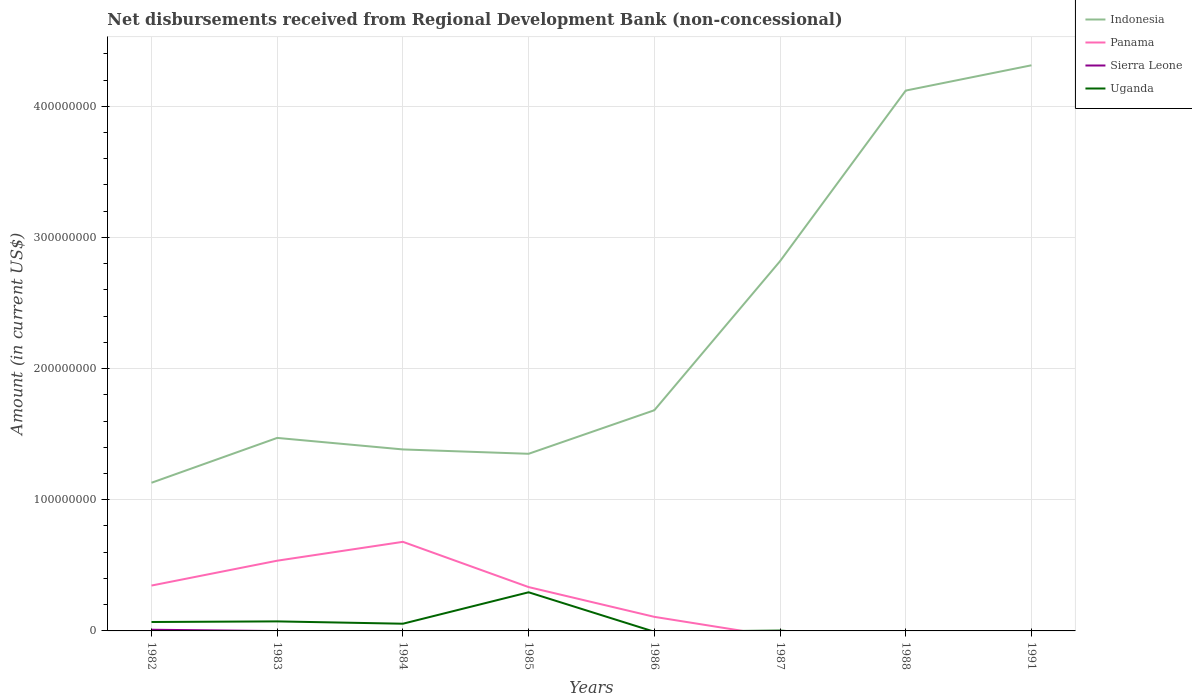How many different coloured lines are there?
Ensure brevity in your answer.  4. Does the line corresponding to Panama intersect with the line corresponding to Sierra Leone?
Provide a short and direct response. Yes. Is the number of lines equal to the number of legend labels?
Your answer should be compact. No. Across all years, what is the maximum amount of disbursements received from Regional Development Bank in Indonesia?
Provide a short and direct response. 1.13e+08. What is the total amount of disbursements received from Regional Development Bank in Indonesia in the graph?
Make the answer very short. -2.96e+08. What is the difference between the highest and the second highest amount of disbursements received from Regional Development Bank in Panama?
Provide a succinct answer. 6.79e+07. What is the difference between the highest and the lowest amount of disbursements received from Regional Development Bank in Uganda?
Ensure brevity in your answer.  3. Is the amount of disbursements received from Regional Development Bank in Uganda strictly greater than the amount of disbursements received from Regional Development Bank in Panama over the years?
Provide a short and direct response. No. How many lines are there?
Give a very brief answer. 4. What is the difference between two consecutive major ticks on the Y-axis?
Provide a succinct answer. 1.00e+08. Are the values on the major ticks of Y-axis written in scientific E-notation?
Provide a short and direct response. No. Does the graph contain any zero values?
Your answer should be compact. Yes. Does the graph contain grids?
Make the answer very short. Yes. How many legend labels are there?
Offer a very short reply. 4. What is the title of the graph?
Offer a terse response. Net disbursements received from Regional Development Bank (non-concessional). What is the Amount (in current US$) in Indonesia in 1982?
Provide a succinct answer. 1.13e+08. What is the Amount (in current US$) in Panama in 1982?
Offer a terse response. 3.46e+07. What is the Amount (in current US$) of Sierra Leone in 1982?
Keep it short and to the point. 9.06e+05. What is the Amount (in current US$) in Uganda in 1982?
Your response must be concise. 6.80e+06. What is the Amount (in current US$) in Indonesia in 1983?
Provide a succinct answer. 1.47e+08. What is the Amount (in current US$) of Panama in 1983?
Your answer should be compact. 5.35e+07. What is the Amount (in current US$) of Uganda in 1983?
Make the answer very short. 7.27e+06. What is the Amount (in current US$) in Indonesia in 1984?
Keep it short and to the point. 1.38e+08. What is the Amount (in current US$) of Panama in 1984?
Ensure brevity in your answer.  6.79e+07. What is the Amount (in current US$) of Uganda in 1984?
Keep it short and to the point. 5.49e+06. What is the Amount (in current US$) of Indonesia in 1985?
Provide a succinct answer. 1.35e+08. What is the Amount (in current US$) in Panama in 1985?
Your answer should be very brief. 3.34e+07. What is the Amount (in current US$) of Uganda in 1985?
Your answer should be very brief. 2.95e+07. What is the Amount (in current US$) in Indonesia in 1986?
Your answer should be compact. 1.68e+08. What is the Amount (in current US$) of Panama in 1986?
Your answer should be compact. 1.07e+07. What is the Amount (in current US$) of Sierra Leone in 1986?
Offer a very short reply. 0. What is the Amount (in current US$) of Indonesia in 1987?
Your response must be concise. 2.82e+08. What is the Amount (in current US$) in Sierra Leone in 1987?
Ensure brevity in your answer.  0. What is the Amount (in current US$) in Uganda in 1987?
Offer a terse response. 2.63e+05. What is the Amount (in current US$) of Indonesia in 1988?
Offer a terse response. 4.12e+08. What is the Amount (in current US$) of Panama in 1988?
Keep it short and to the point. 0. What is the Amount (in current US$) in Sierra Leone in 1988?
Your response must be concise. 0. What is the Amount (in current US$) of Uganda in 1988?
Keep it short and to the point. 0. What is the Amount (in current US$) of Indonesia in 1991?
Provide a short and direct response. 4.31e+08. What is the Amount (in current US$) of Panama in 1991?
Offer a very short reply. 0. Across all years, what is the maximum Amount (in current US$) of Indonesia?
Make the answer very short. 4.31e+08. Across all years, what is the maximum Amount (in current US$) of Panama?
Keep it short and to the point. 6.79e+07. Across all years, what is the maximum Amount (in current US$) of Sierra Leone?
Give a very brief answer. 9.06e+05. Across all years, what is the maximum Amount (in current US$) of Uganda?
Provide a short and direct response. 2.95e+07. Across all years, what is the minimum Amount (in current US$) in Indonesia?
Provide a short and direct response. 1.13e+08. Across all years, what is the minimum Amount (in current US$) in Uganda?
Offer a very short reply. 0. What is the total Amount (in current US$) of Indonesia in the graph?
Your answer should be very brief. 1.83e+09. What is the total Amount (in current US$) in Panama in the graph?
Ensure brevity in your answer.  2.00e+08. What is the total Amount (in current US$) in Sierra Leone in the graph?
Ensure brevity in your answer.  9.06e+05. What is the total Amount (in current US$) of Uganda in the graph?
Offer a very short reply. 4.93e+07. What is the difference between the Amount (in current US$) of Indonesia in 1982 and that in 1983?
Offer a very short reply. -3.42e+07. What is the difference between the Amount (in current US$) in Panama in 1982 and that in 1983?
Your answer should be compact. -1.90e+07. What is the difference between the Amount (in current US$) of Uganda in 1982 and that in 1983?
Make the answer very short. -4.67e+05. What is the difference between the Amount (in current US$) of Indonesia in 1982 and that in 1984?
Your answer should be very brief. -2.54e+07. What is the difference between the Amount (in current US$) of Panama in 1982 and that in 1984?
Provide a succinct answer. -3.33e+07. What is the difference between the Amount (in current US$) of Uganda in 1982 and that in 1984?
Offer a terse response. 1.31e+06. What is the difference between the Amount (in current US$) in Indonesia in 1982 and that in 1985?
Your answer should be compact. -2.21e+07. What is the difference between the Amount (in current US$) of Panama in 1982 and that in 1985?
Your answer should be very brief. 1.17e+06. What is the difference between the Amount (in current US$) in Uganda in 1982 and that in 1985?
Give a very brief answer. -2.27e+07. What is the difference between the Amount (in current US$) of Indonesia in 1982 and that in 1986?
Offer a very short reply. -5.53e+07. What is the difference between the Amount (in current US$) of Panama in 1982 and that in 1986?
Offer a very short reply. 2.39e+07. What is the difference between the Amount (in current US$) in Indonesia in 1982 and that in 1987?
Offer a very short reply. -1.69e+08. What is the difference between the Amount (in current US$) in Uganda in 1982 and that in 1987?
Offer a terse response. 6.54e+06. What is the difference between the Amount (in current US$) in Indonesia in 1982 and that in 1988?
Ensure brevity in your answer.  -2.99e+08. What is the difference between the Amount (in current US$) in Indonesia in 1982 and that in 1991?
Your answer should be compact. -3.18e+08. What is the difference between the Amount (in current US$) in Indonesia in 1983 and that in 1984?
Your answer should be compact. 8.79e+06. What is the difference between the Amount (in current US$) of Panama in 1983 and that in 1984?
Your response must be concise. -1.44e+07. What is the difference between the Amount (in current US$) in Uganda in 1983 and that in 1984?
Your response must be concise. 1.78e+06. What is the difference between the Amount (in current US$) in Indonesia in 1983 and that in 1985?
Your response must be concise. 1.21e+07. What is the difference between the Amount (in current US$) of Panama in 1983 and that in 1985?
Offer a terse response. 2.01e+07. What is the difference between the Amount (in current US$) of Uganda in 1983 and that in 1985?
Ensure brevity in your answer.  -2.22e+07. What is the difference between the Amount (in current US$) in Indonesia in 1983 and that in 1986?
Make the answer very short. -2.11e+07. What is the difference between the Amount (in current US$) of Panama in 1983 and that in 1986?
Your response must be concise. 4.28e+07. What is the difference between the Amount (in current US$) in Indonesia in 1983 and that in 1987?
Give a very brief answer. -1.35e+08. What is the difference between the Amount (in current US$) of Uganda in 1983 and that in 1987?
Your response must be concise. 7.01e+06. What is the difference between the Amount (in current US$) of Indonesia in 1983 and that in 1988?
Ensure brevity in your answer.  -2.65e+08. What is the difference between the Amount (in current US$) of Indonesia in 1983 and that in 1991?
Ensure brevity in your answer.  -2.84e+08. What is the difference between the Amount (in current US$) of Indonesia in 1984 and that in 1985?
Your answer should be compact. 3.32e+06. What is the difference between the Amount (in current US$) of Panama in 1984 and that in 1985?
Your response must be concise. 3.45e+07. What is the difference between the Amount (in current US$) of Uganda in 1984 and that in 1985?
Your response must be concise. -2.40e+07. What is the difference between the Amount (in current US$) of Indonesia in 1984 and that in 1986?
Give a very brief answer. -2.99e+07. What is the difference between the Amount (in current US$) of Panama in 1984 and that in 1986?
Ensure brevity in your answer.  5.72e+07. What is the difference between the Amount (in current US$) in Indonesia in 1984 and that in 1987?
Make the answer very short. -1.44e+08. What is the difference between the Amount (in current US$) in Uganda in 1984 and that in 1987?
Give a very brief answer. 5.23e+06. What is the difference between the Amount (in current US$) in Indonesia in 1984 and that in 1988?
Make the answer very short. -2.74e+08. What is the difference between the Amount (in current US$) in Indonesia in 1984 and that in 1991?
Ensure brevity in your answer.  -2.93e+08. What is the difference between the Amount (in current US$) in Indonesia in 1985 and that in 1986?
Offer a very short reply. -3.32e+07. What is the difference between the Amount (in current US$) of Panama in 1985 and that in 1986?
Offer a terse response. 2.27e+07. What is the difference between the Amount (in current US$) of Indonesia in 1985 and that in 1987?
Your answer should be compact. -1.47e+08. What is the difference between the Amount (in current US$) of Uganda in 1985 and that in 1987?
Give a very brief answer. 2.92e+07. What is the difference between the Amount (in current US$) in Indonesia in 1985 and that in 1988?
Your answer should be very brief. -2.77e+08. What is the difference between the Amount (in current US$) in Indonesia in 1985 and that in 1991?
Give a very brief answer. -2.96e+08. What is the difference between the Amount (in current US$) in Indonesia in 1986 and that in 1987?
Provide a short and direct response. -1.14e+08. What is the difference between the Amount (in current US$) of Indonesia in 1986 and that in 1988?
Make the answer very short. -2.44e+08. What is the difference between the Amount (in current US$) in Indonesia in 1986 and that in 1991?
Keep it short and to the point. -2.63e+08. What is the difference between the Amount (in current US$) of Indonesia in 1987 and that in 1988?
Offer a very short reply. -1.30e+08. What is the difference between the Amount (in current US$) in Indonesia in 1987 and that in 1991?
Your answer should be compact. -1.49e+08. What is the difference between the Amount (in current US$) in Indonesia in 1988 and that in 1991?
Provide a succinct answer. -1.93e+07. What is the difference between the Amount (in current US$) in Indonesia in 1982 and the Amount (in current US$) in Panama in 1983?
Provide a short and direct response. 5.94e+07. What is the difference between the Amount (in current US$) in Indonesia in 1982 and the Amount (in current US$) in Uganda in 1983?
Your response must be concise. 1.06e+08. What is the difference between the Amount (in current US$) of Panama in 1982 and the Amount (in current US$) of Uganda in 1983?
Provide a succinct answer. 2.73e+07. What is the difference between the Amount (in current US$) of Sierra Leone in 1982 and the Amount (in current US$) of Uganda in 1983?
Provide a short and direct response. -6.36e+06. What is the difference between the Amount (in current US$) of Indonesia in 1982 and the Amount (in current US$) of Panama in 1984?
Your answer should be very brief. 4.50e+07. What is the difference between the Amount (in current US$) of Indonesia in 1982 and the Amount (in current US$) of Uganda in 1984?
Make the answer very short. 1.07e+08. What is the difference between the Amount (in current US$) in Panama in 1982 and the Amount (in current US$) in Uganda in 1984?
Provide a short and direct response. 2.91e+07. What is the difference between the Amount (in current US$) in Sierra Leone in 1982 and the Amount (in current US$) in Uganda in 1984?
Keep it short and to the point. -4.58e+06. What is the difference between the Amount (in current US$) of Indonesia in 1982 and the Amount (in current US$) of Panama in 1985?
Your response must be concise. 7.95e+07. What is the difference between the Amount (in current US$) in Indonesia in 1982 and the Amount (in current US$) in Uganda in 1985?
Offer a terse response. 8.35e+07. What is the difference between the Amount (in current US$) of Panama in 1982 and the Amount (in current US$) of Uganda in 1985?
Offer a very short reply. 5.12e+06. What is the difference between the Amount (in current US$) in Sierra Leone in 1982 and the Amount (in current US$) in Uganda in 1985?
Keep it short and to the point. -2.86e+07. What is the difference between the Amount (in current US$) in Indonesia in 1982 and the Amount (in current US$) in Panama in 1986?
Offer a very short reply. 1.02e+08. What is the difference between the Amount (in current US$) of Indonesia in 1982 and the Amount (in current US$) of Uganda in 1987?
Give a very brief answer. 1.13e+08. What is the difference between the Amount (in current US$) of Panama in 1982 and the Amount (in current US$) of Uganda in 1987?
Offer a very short reply. 3.43e+07. What is the difference between the Amount (in current US$) in Sierra Leone in 1982 and the Amount (in current US$) in Uganda in 1987?
Your answer should be compact. 6.43e+05. What is the difference between the Amount (in current US$) of Indonesia in 1983 and the Amount (in current US$) of Panama in 1984?
Keep it short and to the point. 7.92e+07. What is the difference between the Amount (in current US$) of Indonesia in 1983 and the Amount (in current US$) of Uganda in 1984?
Give a very brief answer. 1.42e+08. What is the difference between the Amount (in current US$) of Panama in 1983 and the Amount (in current US$) of Uganda in 1984?
Provide a short and direct response. 4.80e+07. What is the difference between the Amount (in current US$) in Indonesia in 1983 and the Amount (in current US$) in Panama in 1985?
Ensure brevity in your answer.  1.14e+08. What is the difference between the Amount (in current US$) in Indonesia in 1983 and the Amount (in current US$) in Uganda in 1985?
Keep it short and to the point. 1.18e+08. What is the difference between the Amount (in current US$) in Panama in 1983 and the Amount (in current US$) in Uganda in 1985?
Give a very brief answer. 2.41e+07. What is the difference between the Amount (in current US$) of Indonesia in 1983 and the Amount (in current US$) of Panama in 1986?
Offer a terse response. 1.36e+08. What is the difference between the Amount (in current US$) of Indonesia in 1983 and the Amount (in current US$) of Uganda in 1987?
Your response must be concise. 1.47e+08. What is the difference between the Amount (in current US$) of Panama in 1983 and the Amount (in current US$) of Uganda in 1987?
Your answer should be very brief. 5.33e+07. What is the difference between the Amount (in current US$) of Indonesia in 1984 and the Amount (in current US$) of Panama in 1985?
Provide a succinct answer. 1.05e+08. What is the difference between the Amount (in current US$) of Indonesia in 1984 and the Amount (in current US$) of Uganda in 1985?
Provide a succinct answer. 1.09e+08. What is the difference between the Amount (in current US$) of Panama in 1984 and the Amount (in current US$) of Uganda in 1985?
Provide a succinct answer. 3.85e+07. What is the difference between the Amount (in current US$) in Indonesia in 1984 and the Amount (in current US$) in Panama in 1986?
Your response must be concise. 1.28e+08. What is the difference between the Amount (in current US$) in Indonesia in 1984 and the Amount (in current US$) in Uganda in 1987?
Provide a short and direct response. 1.38e+08. What is the difference between the Amount (in current US$) in Panama in 1984 and the Amount (in current US$) in Uganda in 1987?
Your answer should be compact. 6.77e+07. What is the difference between the Amount (in current US$) in Indonesia in 1985 and the Amount (in current US$) in Panama in 1986?
Provide a succinct answer. 1.24e+08. What is the difference between the Amount (in current US$) in Indonesia in 1985 and the Amount (in current US$) in Uganda in 1987?
Keep it short and to the point. 1.35e+08. What is the difference between the Amount (in current US$) of Panama in 1985 and the Amount (in current US$) of Uganda in 1987?
Provide a short and direct response. 3.32e+07. What is the difference between the Amount (in current US$) of Indonesia in 1986 and the Amount (in current US$) of Uganda in 1987?
Ensure brevity in your answer.  1.68e+08. What is the difference between the Amount (in current US$) in Panama in 1986 and the Amount (in current US$) in Uganda in 1987?
Your answer should be compact. 1.05e+07. What is the average Amount (in current US$) in Indonesia per year?
Your response must be concise. 2.28e+08. What is the average Amount (in current US$) in Panama per year?
Ensure brevity in your answer.  2.50e+07. What is the average Amount (in current US$) in Sierra Leone per year?
Your answer should be very brief. 1.13e+05. What is the average Amount (in current US$) of Uganda per year?
Ensure brevity in your answer.  6.16e+06. In the year 1982, what is the difference between the Amount (in current US$) in Indonesia and Amount (in current US$) in Panama?
Your answer should be compact. 7.84e+07. In the year 1982, what is the difference between the Amount (in current US$) in Indonesia and Amount (in current US$) in Sierra Leone?
Make the answer very short. 1.12e+08. In the year 1982, what is the difference between the Amount (in current US$) of Indonesia and Amount (in current US$) of Uganda?
Give a very brief answer. 1.06e+08. In the year 1982, what is the difference between the Amount (in current US$) in Panama and Amount (in current US$) in Sierra Leone?
Give a very brief answer. 3.37e+07. In the year 1982, what is the difference between the Amount (in current US$) in Panama and Amount (in current US$) in Uganda?
Offer a very short reply. 2.78e+07. In the year 1982, what is the difference between the Amount (in current US$) of Sierra Leone and Amount (in current US$) of Uganda?
Make the answer very short. -5.90e+06. In the year 1983, what is the difference between the Amount (in current US$) of Indonesia and Amount (in current US$) of Panama?
Provide a succinct answer. 9.36e+07. In the year 1983, what is the difference between the Amount (in current US$) of Indonesia and Amount (in current US$) of Uganda?
Your answer should be very brief. 1.40e+08. In the year 1983, what is the difference between the Amount (in current US$) in Panama and Amount (in current US$) in Uganda?
Offer a terse response. 4.63e+07. In the year 1984, what is the difference between the Amount (in current US$) of Indonesia and Amount (in current US$) of Panama?
Give a very brief answer. 7.04e+07. In the year 1984, what is the difference between the Amount (in current US$) of Indonesia and Amount (in current US$) of Uganda?
Ensure brevity in your answer.  1.33e+08. In the year 1984, what is the difference between the Amount (in current US$) in Panama and Amount (in current US$) in Uganda?
Offer a terse response. 6.24e+07. In the year 1985, what is the difference between the Amount (in current US$) in Indonesia and Amount (in current US$) in Panama?
Keep it short and to the point. 1.02e+08. In the year 1985, what is the difference between the Amount (in current US$) in Indonesia and Amount (in current US$) in Uganda?
Offer a terse response. 1.06e+08. In the year 1985, what is the difference between the Amount (in current US$) in Panama and Amount (in current US$) in Uganda?
Offer a very short reply. 3.96e+06. In the year 1986, what is the difference between the Amount (in current US$) in Indonesia and Amount (in current US$) in Panama?
Make the answer very short. 1.57e+08. In the year 1987, what is the difference between the Amount (in current US$) in Indonesia and Amount (in current US$) in Uganda?
Make the answer very short. 2.82e+08. What is the ratio of the Amount (in current US$) in Indonesia in 1982 to that in 1983?
Your answer should be very brief. 0.77. What is the ratio of the Amount (in current US$) of Panama in 1982 to that in 1983?
Keep it short and to the point. 0.65. What is the ratio of the Amount (in current US$) in Uganda in 1982 to that in 1983?
Keep it short and to the point. 0.94. What is the ratio of the Amount (in current US$) in Indonesia in 1982 to that in 1984?
Provide a succinct answer. 0.82. What is the ratio of the Amount (in current US$) of Panama in 1982 to that in 1984?
Make the answer very short. 0.51. What is the ratio of the Amount (in current US$) of Uganda in 1982 to that in 1984?
Give a very brief answer. 1.24. What is the ratio of the Amount (in current US$) in Indonesia in 1982 to that in 1985?
Ensure brevity in your answer.  0.84. What is the ratio of the Amount (in current US$) in Panama in 1982 to that in 1985?
Provide a succinct answer. 1.03. What is the ratio of the Amount (in current US$) in Uganda in 1982 to that in 1985?
Your response must be concise. 0.23. What is the ratio of the Amount (in current US$) in Indonesia in 1982 to that in 1986?
Make the answer very short. 0.67. What is the ratio of the Amount (in current US$) of Panama in 1982 to that in 1986?
Your response must be concise. 3.22. What is the ratio of the Amount (in current US$) in Indonesia in 1982 to that in 1987?
Your response must be concise. 0.4. What is the ratio of the Amount (in current US$) of Uganda in 1982 to that in 1987?
Offer a terse response. 25.86. What is the ratio of the Amount (in current US$) in Indonesia in 1982 to that in 1988?
Keep it short and to the point. 0.27. What is the ratio of the Amount (in current US$) of Indonesia in 1982 to that in 1991?
Your answer should be compact. 0.26. What is the ratio of the Amount (in current US$) in Indonesia in 1983 to that in 1984?
Your answer should be compact. 1.06. What is the ratio of the Amount (in current US$) in Panama in 1983 to that in 1984?
Provide a succinct answer. 0.79. What is the ratio of the Amount (in current US$) in Uganda in 1983 to that in 1984?
Provide a short and direct response. 1.32. What is the ratio of the Amount (in current US$) of Indonesia in 1983 to that in 1985?
Offer a terse response. 1.09. What is the ratio of the Amount (in current US$) in Panama in 1983 to that in 1985?
Your answer should be very brief. 1.6. What is the ratio of the Amount (in current US$) in Uganda in 1983 to that in 1985?
Give a very brief answer. 0.25. What is the ratio of the Amount (in current US$) of Indonesia in 1983 to that in 1986?
Provide a succinct answer. 0.87. What is the ratio of the Amount (in current US$) of Panama in 1983 to that in 1986?
Your response must be concise. 4.99. What is the ratio of the Amount (in current US$) in Indonesia in 1983 to that in 1987?
Provide a succinct answer. 0.52. What is the ratio of the Amount (in current US$) in Uganda in 1983 to that in 1987?
Provide a short and direct response. 27.64. What is the ratio of the Amount (in current US$) of Indonesia in 1983 to that in 1988?
Offer a terse response. 0.36. What is the ratio of the Amount (in current US$) of Indonesia in 1983 to that in 1991?
Keep it short and to the point. 0.34. What is the ratio of the Amount (in current US$) in Indonesia in 1984 to that in 1985?
Your answer should be compact. 1.02. What is the ratio of the Amount (in current US$) of Panama in 1984 to that in 1985?
Provide a succinct answer. 2.03. What is the ratio of the Amount (in current US$) in Uganda in 1984 to that in 1985?
Your answer should be very brief. 0.19. What is the ratio of the Amount (in current US$) of Indonesia in 1984 to that in 1986?
Your answer should be compact. 0.82. What is the ratio of the Amount (in current US$) in Panama in 1984 to that in 1986?
Give a very brief answer. 6.33. What is the ratio of the Amount (in current US$) of Indonesia in 1984 to that in 1987?
Offer a very short reply. 0.49. What is the ratio of the Amount (in current US$) of Uganda in 1984 to that in 1987?
Provide a short and direct response. 20.87. What is the ratio of the Amount (in current US$) of Indonesia in 1984 to that in 1988?
Keep it short and to the point. 0.34. What is the ratio of the Amount (in current US$) in Indonesia in 1984 to that in 1991?
Ensure brevity in your answer.  0.32. What is the ratio of the Amount (in current US$) in Indonesia in 1985 to that in 1986?
Your answer should be compact. 0.8. What is the ratio of the Amount (in current US$) of Panama in 1985 to that in 1986?
Offer a very short reply. 3.11. What is the ratio of the Amount (in current US$) in Indonesia in 1985 to that in 1987?
Provide a succinct answer. 0.48. What is the ratio of the Amount (in current US$) in Uganda in 1985 to that in 1987?
Your response must be concise. 112.02. What is the ratio of the Amount (in current US$) in Indonesia in 1985 to that in 1988?
Keep it short and to the point. 0.33. What is the ratio of the Amount (in current US$) in Indonesia in 1985 to that in 1991?
Your answer should be compact. 0.31. What is the ratio of the Amount (in current US$) in Indonesia in 1986 to that in 1987?
Provide a succinct answer. 0.6. What is the ratio of the Amount (in current US$) in Indonesia in 1986 to that in 1988?
Your response must be concise. 0.41. What is the ratio of the Amount (in current US$) in Indonesia in 1986 to that in 1991?
Give a very brief answer. 0.39. What is the ratio of the Amount (in current US$) in Indonesia in 1987 to that in 1988?
Your answer should be very brief. 0.68. What is the ratio of the Amount (in current US$) in Indonesia in 1987 to that in 1991?
Keep it short and to the point. 0.65. What is the ratio of the Amount (in current US$) of Indonesia in 1988 to that in 1991?
Offer a terse response. 0.96. What is the difference between the highest and the second highest Amount (in current US$) of Indonesia?
Your answer should be very brief. 1.93e+07. What is the difference between the highest and the second highest Amount (in current US$) of Panama?
Your response must be concise. 1.44e+07. What is the difference between the highest and the second highest Amount (in current US$) in Uganda?
Your answer should be very brief. 2.22e+07. What is the difference between the highest and the lowest Amount (in current US$) of Indonesia?
Keep it short and to the point. 3.18e+08. What is the difference between the highest and the lowest Amount (in current US$) in Panama?
Offer a very short reply. 6.79e+07. What is the difference between the highest and the lowest Amount (in current US$) in Sierra Leone?
Your answer should be compact. 9.06e+05. What is the difference between the highest and the lowest Amount (in current US$) in Uganda?
Your answer should be very brief. 2.95e+07. 